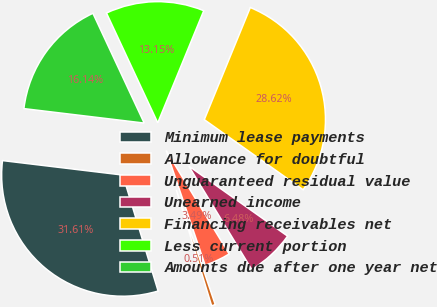Convert chart to OTSL. <chart><loc_0><loc_0><loc_500><loc_500><pie_chart><fcel>Minimum lease payments<fcel>Allowance for doubtful<fcel>Unguaranteed residual value<fcel>Unearned income<fcel>Financing receivables net<fcel>Less current portion<fcel>Amounts due after one year net<nl><fcel>31.61%<fcel>0.51%<fcel>3.49%<fcel>6.48%<fcel>28.62%<fcel>13.15%<fcel>16.14%<nl></chart> 